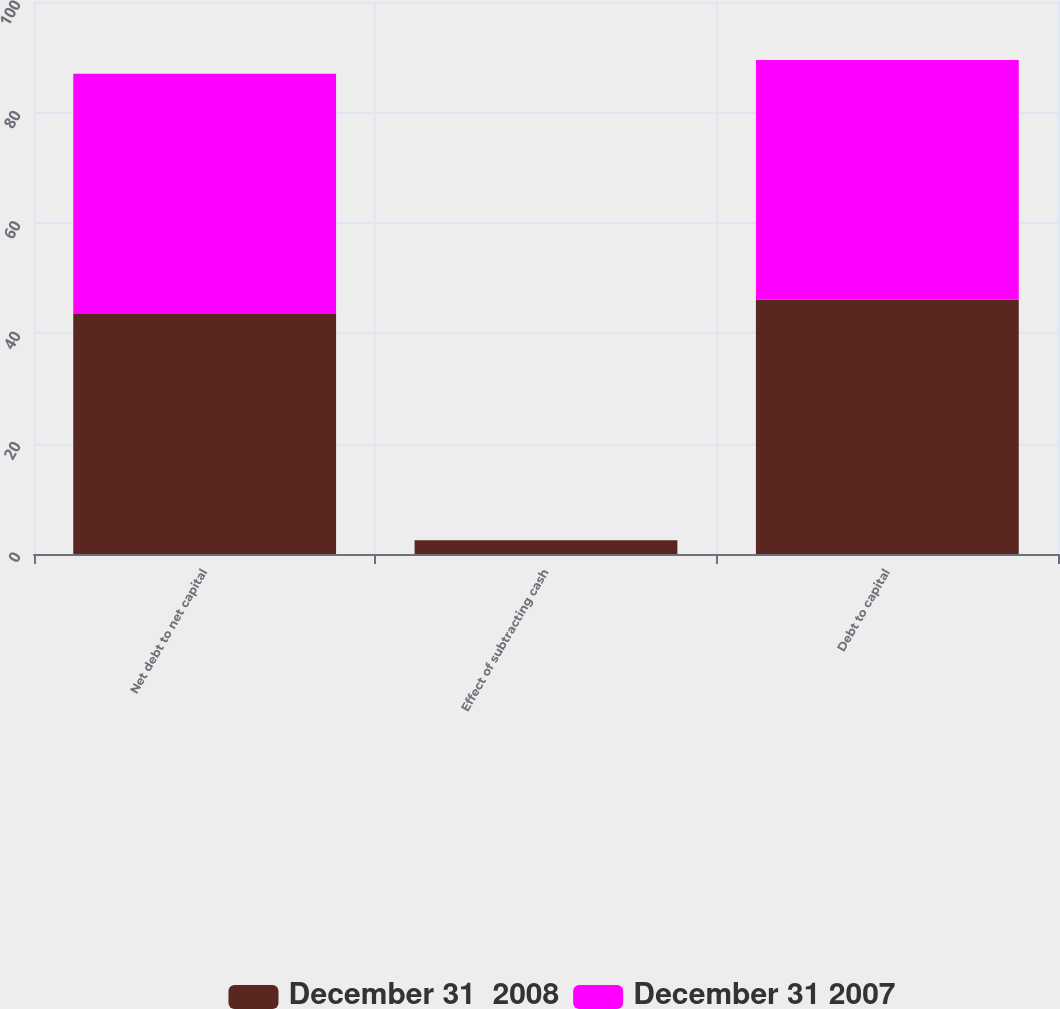Convert chart to OTSL. <chart><loc_0><loc_0><loc_500><loc_500><stacked_bar_chart><ecel><fcel>Net debt to net capital<fcel>Effect of subtracting cash<fcel>Debt to capital<nl><fcel>December 31  2008<fcel>43.6<fcel>2.5<fcel>46.1<nl><fcel>December 31 2007<fcel>43.4<fcel>0<fcel>43.4<nl></chart> 